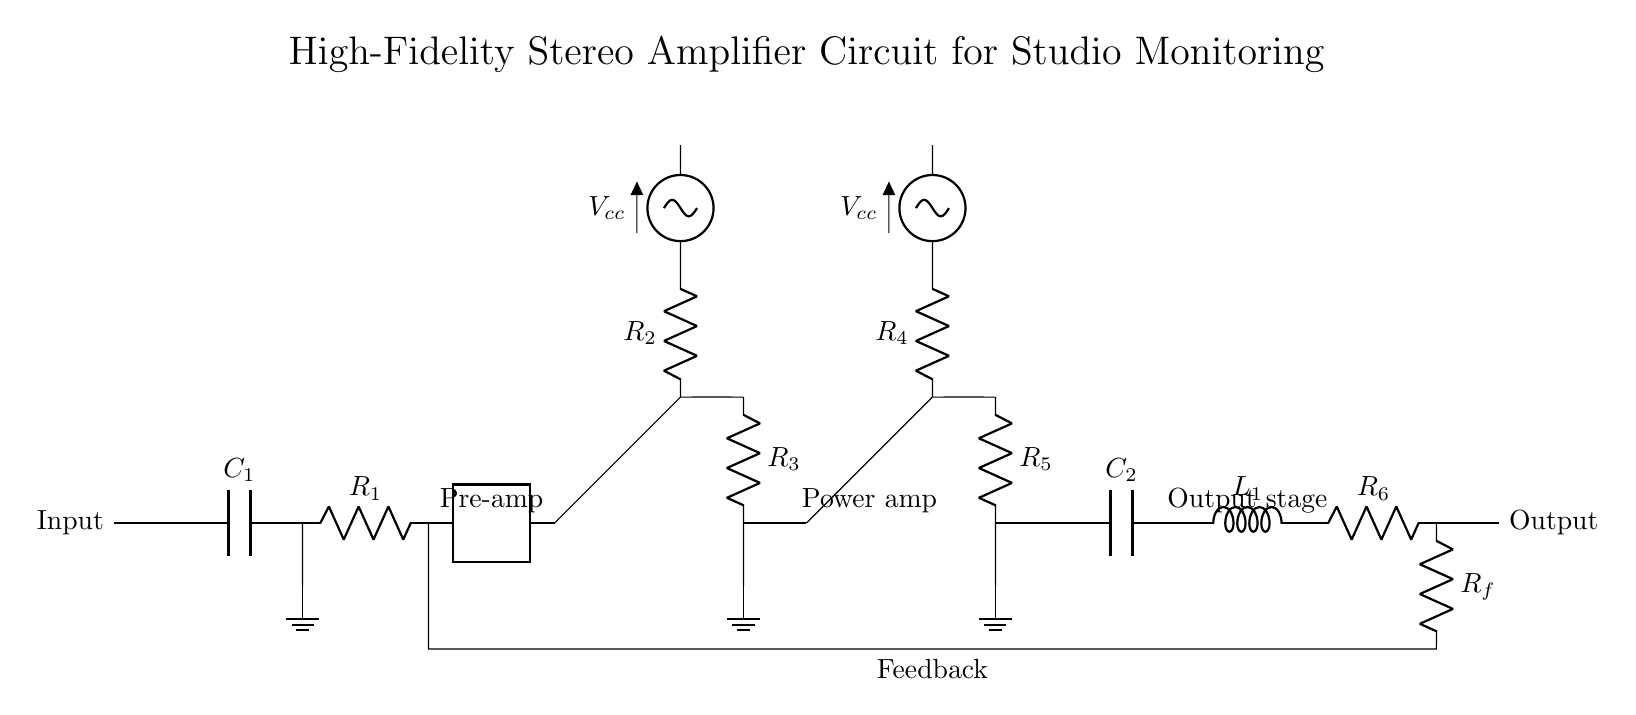What is the function of C1 in the circuit? C1 acts as a coupling capacitor, allowing AC signals to pass while blocking DC components. It is crucial for maintaining signal quality and preventing DC offset at the input stage.
Answer: Coupling capacitor What type of transistors are used in the pre-amplifier stage? The circuit uses a PNP transistor in the pre-amplifier stage. It can be identified as it amplifies current and is connected to the positive supply voltage.
Answer: PNP How is feedback implemented in this amplifier? Feedback is implemented using resistor Rf, which connects the output back to the input side of the circuit. This connection helps stabilize gain and improve linearity by reducing distortion.
Answer: Resistor Rf What components are included in the output stage? The output stage includes a capacitor C2, an inductor L1, and a resistor R6, which together smooth out the output signal and protect against high-frequency noise.
Answer: C2, L1, R6 What is the purpose of R2 in the circuit? R2 is part of the pre-amplifier stage and is used to control the biasing of the PNP transistor. This ensures that the transistor operates in the linear region for proper amplification of the input signal.
Answer: Biasing What is the total number of resistors in the circuit? There are four resistors present in this amplifier circuit: R1, R2, R3, and R4. Each resistor plays a specific role in determining gain, biasing, and feedback.
Answer: Four 